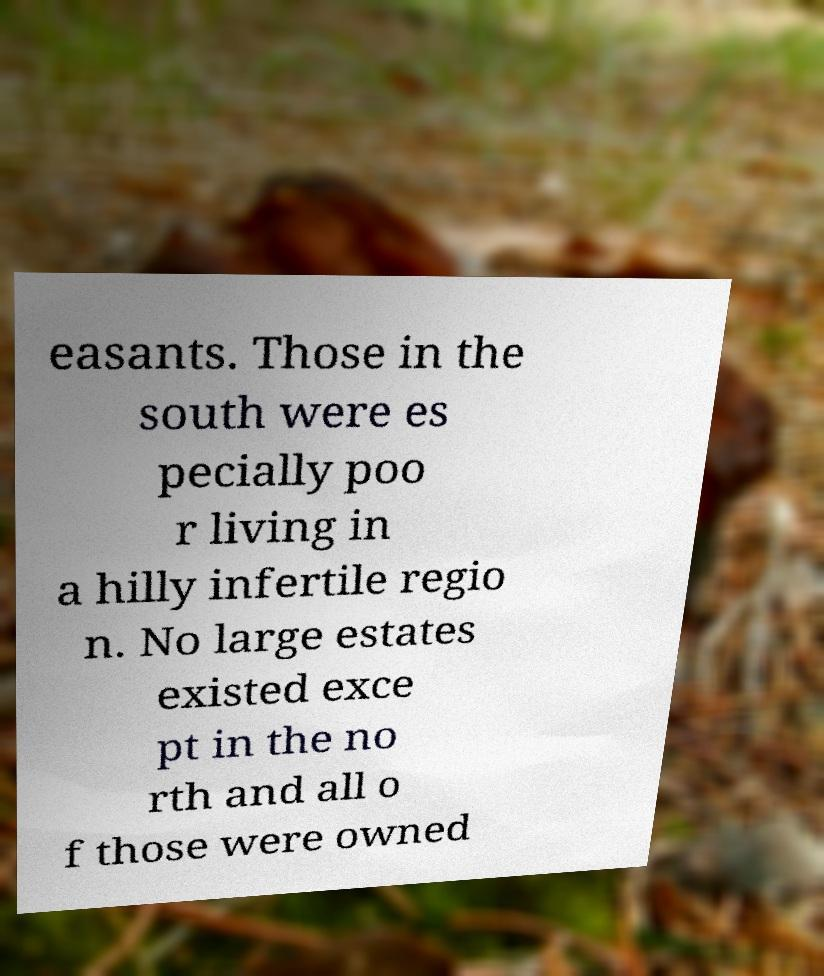Could you extract and type out the text from this image? easants. Those in the south were es pecially poo r living in a hilly infertile regio n. No large estates existed exce pt in the no rth and all o f those were owned 